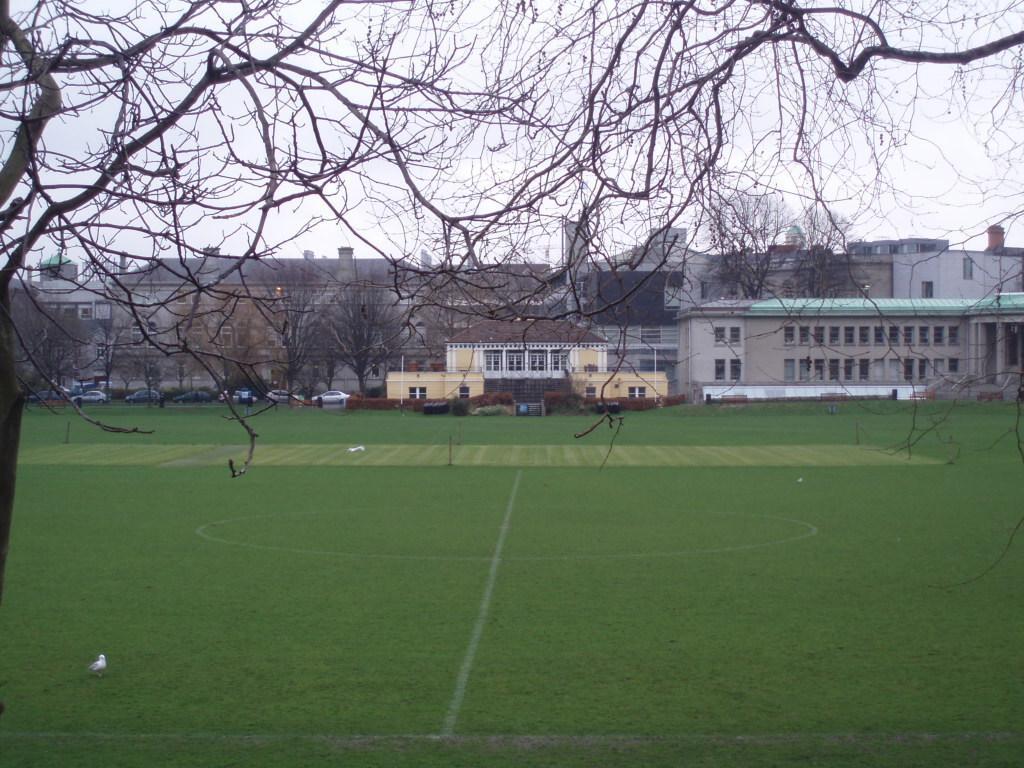Could you give a brief overview of what you see in this image? In this image I can see buildings, in front of buildings I can see there is a ground, vehicles, trees, at the top there is the sky. 